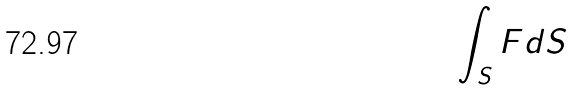Convert formula to latex. <formula><loc_0><loc_0><loc_500><loc_500>\int _ { S } F d S</formula> 